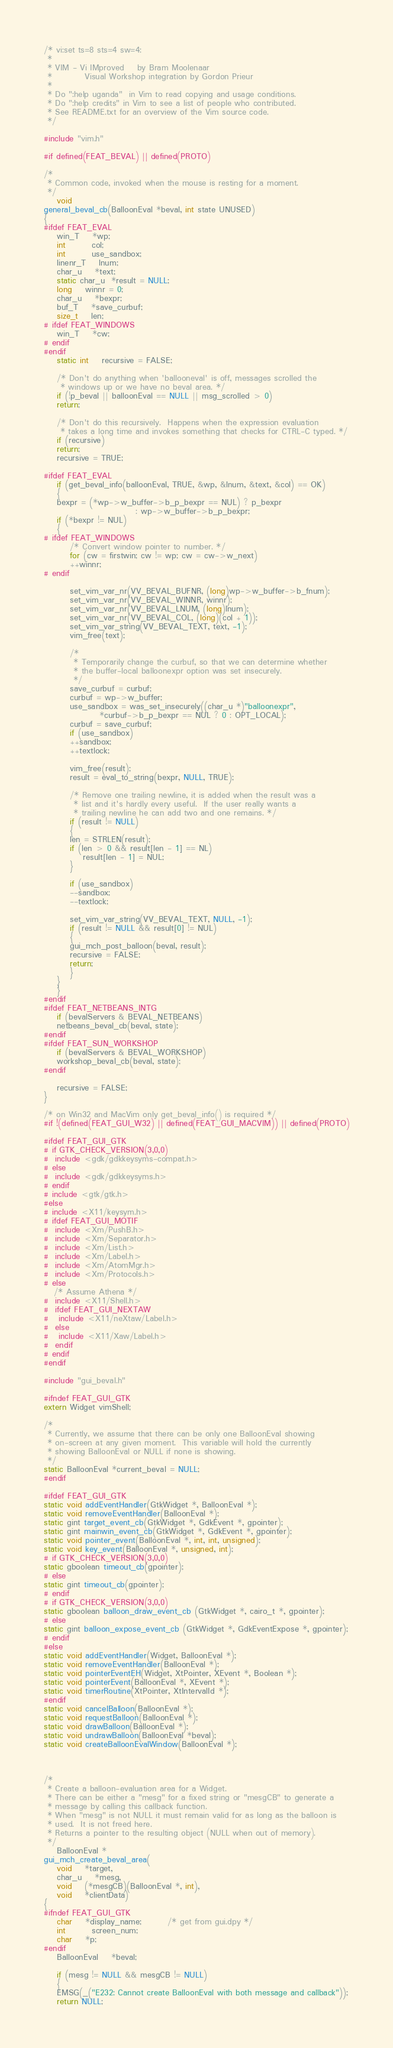<code> <loc_0><loc_0><loc_500><loc_500><_C_>/* vi:set ts=8 sts=4 sw=4:
 *
 * VIM - Vi IMproved	by Bram Moolenaar
 *			Visual Workshop integration by Gordon Prieur
 *
 * Do ":help uganda"  in Vim to read copying and usage conditions.
 * Do ":help credits" in Vim to see a list of people who contributed.
 * See README.txt for an overview of the Vim source code.
 */

#include "vim.h"

#if defined(FEAT_BEVAL) || defined(PROTO)

/*
 * Common code, invoked when the mouse is resting for a moment.
 */
    void
general_beval_cb(BalloonEval *beval, int state UNUSED)
{
#ifdef FEAT_EVAL
    win_T	*wp;
    int		col;
    int		use_sandbox;
    linenr_T	lnum;
    char_u	*text;
    static char_u  *result = NULL;
    long	winnr = 0;
    char_u	*bexpr;
    buf_T	*save_curbuf;
    size_t	len;
# ifdef FEAT_WINDOWS
    win_T	*cw;
# endif
#endif
    static int	recursive = FALSE;

    /* Don't do anything when 'ballooneval' is off, messages scrolled the
     * windows up or we have no beval area. */
    if (!p_beval || balloonEval == NULL || msg_scrolled > 0)
	return;

    /* Don't do this recursively.  Happens when the expression evaluation
     * takes a long time and invokes something that checks for CTRL-C typed. */
    if (recursive)
	return;
    recursive = TRUE;

#ifdef FEAT_EVAL
    if (get_beval_info(balloonEval, TRUE, &wp, &lnum, &text, &col) == OK)
    {
	bexpr = (*wp->w_buffer->b_p_bexpr == NUL) ? p_bexpr
						    : wp->w_buffer->b_p_bexpr;
	if (*bexpr != NUL)
	{
# ifdef FEAT_WINDOWS
	    /* Convert window pointer to number. */
	    for (cw = firstwin; cw != wp; cw = cw->w_next)
		++winnr;
# endif

	    set_vim_var_nr(VV_BEVAL_BUFNR, (long)wp->w_buffer->b_fnum);
	    set_vim_var_nr(VV_BEVAL_WINNR, winnr);
	    set_vim_var_nr(VV_BEVAL_LNUM, (long)lnum);
	    set_vim_var_nr(VV_BEVAL_COL, (long)(col + 1));
	    set_vim_var_string(VV_BEVAL_TEXT, text, -1);
	    vim_free(text);

	    /*
	     * Temporarily change the curbuf, so that we can determine whether
	     * the buffer-local balloonexpr option was set insecurely.
	     */
	    save_curbuf = curbuf;
	    curbuf = wp->w_buffer;
	    use_sandbox = was_set_insecurely((char_u *)"balloonexpr",
				 *curbuf->b_p_bexpr == NUL ? 0 : OPT_LOCAL);
	    curbuf = save_curbuf;
	    if (use_sandbox)
		++sandbox;
	    ++textlock;

	    vim_free(result);
	    result = eval_to_string(bexpr, NULL, TRUE);

	    /* Remove one trailing newline, it is added when the result was a
	     * list and it's hardly every useful.  If the user really wants a
	     * trailing newline he can add two and one remains. */
	    if (result != NULL)
	    {
		len = STRLEN(result);
		if (len > 0 && result[len - 1] == NL)
		    result[len - 1] = NUL;
	    }

	    if (use_sandbox)
		--sandbox;
	    --textlock;

	    set_vim_var_string(VV_BEVAL_TEXT, NULL, -1);
	    if (result != NULL && result[0] != NUL)
	    {
		gui_mch_post_balloon(beval, result);
		recursive = FALSE;
		return;
	    }
	}
    }
#endif
#ifdef FEAT_NETBEANS_INTG
    if (bevalServers & BEVAL_NETBEANS)
	netbeans_beval_cb(beval, state);
#endif
#ifdef FEAT_SUN_WORKSHOP
    if (bevalServers & BEVAL_WORKSHOP)
	workshop_beval_cb(beval, state);
#endif

    recursive = FALSE;
}

/* on Win32 and MacVim only get_beval_info() is required */
#if !(defined(FEAT_GUI_W32) || defined(FEAT_GUI_MACVIM)) || defined(PROTO)

#ifdef FEAT_GUI_GTK
# if GTK_CHECK_VERSION(3,0,0)
#  include <gdk/gdkkeysyms-compat.h>
# else
#  include <gdk/gdkkeysyms.h>
# endif
# include <gtk/gtk.h>
#else
# include <X11/keysym.h>
# ifdef FEAT_GUI_MOTIF
#  include <Xm/PushB.h>
#  include <Xm/Separator.h>
#  include <Xm/List.h>
#  include <Xm/Label.h>
#  include <Xm/AtomMgr.h>
#  include <Xm/Protocols.h>
# else
   /* Assume Athena */
#  include <X11/Shell.h>
#  ifdef FEAT_GUI_NEXTAW
#   include <X11/neXtaw/Label.h>
#  else
#   include <X11/Xaw/Label.h>
#  endif
# endif
#endif

#include "gui_beval.h"

#ifndef FEAT_GUI_GTK
extern Widget vimShell;

/*
 * Currently, we assume that there can be only one BalloonEval showing
 * on-screen at any given moment.  This variable will hold the currently
 * showing BalloonEval or NULL if none is showing.
 */
static BalloonEval *current_beval = NULL;
#endif

#ifdef FEAT_GUI_GTK
static void addEventHandler(GtkWidget *, BalloonEval *);
static void removeEventHandler(BalloonEval *);
static gint target_event_cb(GtkWidget *, GdkEvent *, gpointer);
static gint mainwin_event_cb(GtkWidget *, GdkEvent *, gpointer);
static void pointer_event(BalloonEval *, int, int, unsigned);
static void key_event(BalloonEval *, unsigned, int);
# if GTK_CHECK_VERSION(3,0,0)
static gboolean timeout_cb(gpointer);
# else
static gint timeout_cb(gpointer);
# endif
# if GTK_CHECK_VERSION(3,0,0)
static gboolean balloon_draw_event_cb (GtkWidget *, cairo_t *, gpointer);
# else
static gint balloon_expose_event_cb (GtkWidget *, GdkEventExpose *, gpointer);
# endif
#else
static void addEventHandler(Widget, BalloonEval *);
static void removeEventHandler(BalloonEval *);
static void pointerEventEH(Widget, XtPointer, XEvent *, Boolean *);
static void pointerEvent(BalloonEval *, XEvent *);
static void timerRoutine(XtPointer, XtIntervalId *);
#endif
static void cancelBalloon(BalloonEval *);
static void requestBalloon(BalloonEval *);
static void drawBalloon(BalloonEval *);
static void undrawBalloon(BalloonEval *beval);
static void createBalloonEvalWindow(BalloonEval *);



/*
 * Create a balloon-evaluation area for a Widget.
 * There can be either a "mesg" for a fixed string or "mesgCB" to generate a
 * message by calling this callback function.
 * When "mesg" is not NULL it must remain valid for as long as the balloon is
 * used.  It is not freed here.
 * Returns a pointer to the resulting object (NULL when out of memory).
 */
    BalloonEval *
gui_mch_create_beval_area(
    void	*target,
    char_u	*mesg,
    void	(*mesgCB)(BalloonEval *, int),
    void	*clientData)
{
#ifndef FEAT_GUI_GTK
    char	*display_name;	    /* get from gui.dpy */
    int		screen_num;
    char	*p;
#endif
    BalloonEval	*beval;

    if (mesg != NULL && mesgCB != NULL)
    {
	EMSG(_("E232: Cannot create BalloonEval with both message and callback"));
	return NULL;</code> 